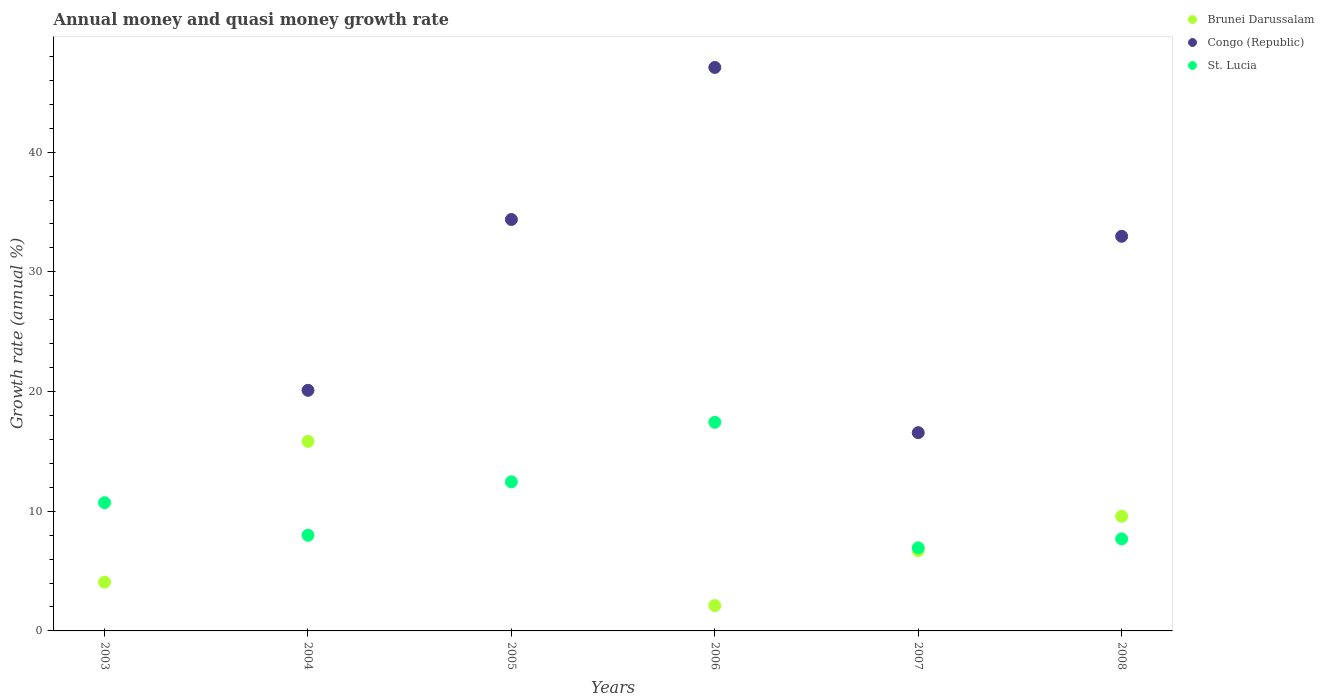Is the number of dotlines equal to the number of legend labels?
Offer a terse response. No. Across all years, what is the maximum growth rate in Congo (Republic)?
Give a very brief answer. 47.08. What is the total growth rate in Brunei Darussalam in the graph?
Your answer should be very brief. 38.31. What is the difference between the growth rate in Congo (Republic) in 2004 and that in 2006?
Provide a short and direct response. -26.97. What is the difference between the growth rate in St. Lucia in 2003 and the growth rate in Brunei Darussalam in 2007?
Offer a terse response. 4.01. What is the average growth rate in Brunei Darussalam per year?
Make the answer very short. 6.38. In the year 2008, what is the difference between the growth rate in St. Lucia and growth rate in Congo (Republic)?
Your answer should be very brief. -25.28. In how many years, is the growth rate in Brunei Darussalam greater than 16 %?
Provide a succinct answer. 0. What is the ratio of the growth rate in St. Lucia in 2003 to that in 2005?
Give a very brief answer. 0.86. What is the difference between the highest and the second highest growth rate in Brunei Darussalam?
Offer a terse response. 6.26. What is the difference between the highest and the lowest growth rate in Congo (Republic)?
Your response must be concise. 47.08. In how many years, is the growth rate in Brunei Darussalam greater than the average growth rate in Brunei Darussalam taken over all years?
Ensure brevity in your answer.  3. Does the growth rate in Congo (Republic) monotonically increase over the years?
Your answer should be compact. No. What is the difference between two consecutive major ticks on the Y-axis?
Provide a short and direct response. 10. Are the values on the major ticks of Y-axis written in scientific E-notation?
Offer a very short reply. No. Does the graph contain any zero values?
Your answer should be compact. Yes. Where does the legend appear in the graph?
Make the answer very short. Top right. What is the title of the graph?
Offer a terse response. Annual money and quasi money growth rate. What is the label or title of the Y-axis?
Keep it short and to the point. Growth rate (annual %). What is the Growth rate (annual %) in Brunei Darussalam in 2003?
Keep it short and to the point. 4.07. What is the Growth rate (annual %) in St. Lucia in 2003?
Offer a terse response. 10.71. What is the Growth rate (annual %) in Brunei Darussalam in 2004?
Give a very brief answer. 15.83. What is the Growth rate (annual %) in Congo (Republic) in 2004?
Keep it short and to the point. 20.1. What is the Growth rate (annual %) in St. Lucia in 2004?
Offer a terse response. 7.99. What is the Growth rate (annual %) in Congo (Republic) in 2005?
Keep it short and to the point. 34.37. What is the Growth rate (annual %) of St. Lucia in 2005?
Your answer should be very brief. 12.46. What is the Growth rate (annual %) of Brunei Darussalam in 2006?
Provide a short and direct response. 2.12. What is the Growth rate (annual %) in Congo (Republic) in 2006?
Give a very brief answer. 47.08. What is the Growth rate (annual %) in St. Lucia in 2006?
Your response must be concise. 17.43. What is the Growth rate (annual %) in Brunei Darussalam in 2007?
Make the answer very short. 6.71. What is the Growth rate (annual %) of Congo (Republic) in 2007?
Offer a very short reply. 16.56. What is the Growth rate (annual %) in St. Lucia in 2007?
Your response must be concise. 6.95. What is the Growth rate (annual %) of Brunei Darussalam in 2008?
Offer a terse response. 9.58. What is the Growth rate (annual %) in Congo (Republic) in 2008?
Your answer should be very brief. 32.97. What is the Growth rate (annual %) of St. Lucia in 2008?
Offer a very short reply. 7.69. Across all years, what is the maximum Growth rate (annual %) of Brunei Darussalam?
Provide a succinct answer. 15.83. Across all years, what is the maximum Growth rate (annual %) in Congo (Republic)?
Ensure brevity in your answer.  47.08. Across all years, what is the maximum Growth rate (annual %) of St. Lucia?
Your answer should be compact. 17.43. Across all years, what is the minimum Growth rate (annual %) of St. Lucia?
Offer a terse response. 6.95. What is the total Growth rate (annual %) in Brunei Darussalam in the graph?
Keep it short and to the point. 38.31. What is the total Growth rate (annual %) of Congo (Republic) in the graph?
Provide a short and direct response. 151.08. What is the total Growth rate (annual %) in St. Lucia in the graph?
Offer a terse response. 63.22. What is the difference between the Growth rate (annual %) in Brunei Darussalam in 2003 and that in 2004?
Offer a very short reply. -11.76. What is the difference between the Growth rate (annual %) in St. Lucia in 2003 and that in 2004?
Offer a terse response. 2.72. What is the difference between the Growth rate (annual %) of St. Lucia in 2003 and that in 2005?
Offer a terse response. -1.74. What is the difference between the Growth rate (annual %) of Brunei Darussalam in 2003 and that in 2006?
Keep it short and to the point. 1.95. What is the difference between the Growth rate (annual %) in St. Lucia in 2003 and that in 2006?
Provide a succinct answer. -6.72. What is the difference between the Growth rate (annual %) of Brunei Darussalam in 2003 and that in 2007?
Your response must be concise. -2.64. What is the difference between the Growth rate (annual %) in St. Lucia in 2003 and that in 2007?
Keep it short and to the point. 3.77. What is the difference between the Growth rate (annual %) of Brunei Darussalam in 2003 and that in 2008?
Provide a short and direct response. -5.51. What is the difference between the Growth rate (annual %) of St. Lucia in 2003 and that in 2008?
Provide a short and direct response. 3.02. What is the difference between the Growth rate (annual %) in Congo (Republic) in 2004 and that in 2005?
Your answer should be very brief. -14.27. What is the difference between the Growth rate (annual %) in St. Lucia in 2004 and that in 2005?
Your answer should be compact. -4.47. What is the difference between the Growth rate (annual %) in Brunei Darussalam in 2004 and that in 2006?
Give a very brief answer. 13.72. What is the difference between the Growth rate (annual %) of Congo (Republic) in 2004 and that in 2006?
Make the answer very short. -26.97. What is the difference between the Growth rate (annual %) of St. Lucia in 2004 and that in 2006?
Your response must be concise. -9.44. What is the difference between the Growth rate (annual %) of Brunei Darussalam in 2004 and that in 2007?
Your response must be concise. 9.13. What is the difference between the Growth rate (annual %) in Congo (Republic) in 2004 and that in 2007?
Provide a succinct answer. 3.54. What is the difference between the Growth rate (annual %) of St. Lucia in 2004 and that in 2007?
Your answer should be compact. 1.05. What is the difference between the Growth rate (annual %) in Brunei Darussalam in 2004 and that in 2008?
Ensure brevity in your answer.  6.26. What is the difference between the Growth rate (annual %) of Congo (Republic) in 2004 and that in 2008?
Make the answer very short. -12.87. What is the difference between the Growth rate (annual %) in St. Lucia in 2004 and that in 2008?
Keep it short and to the point. 0.3. What is the difference between the Growth rate (annual %) of Congo (Republic) in 2005 and that in 2006?
Ensure brevity in your answer.  -12.7. What is the difference between the Growth rate (annual %) in St. Lucia in 2005 and that in 2006?
Keep it short and to the point. -4.98. What is the difference between the Growth rate (annual %) of Congo (Republic) in 2005 and that in 2007?
Ensure brevity in your answer.  17.81. What is the difference between the Growth rate (annual %) of St. Lucia in 2005 and that in 2007?
Make the answer very short. 5.51. What is the difference between the Growth rate (annual %) in Congo (Republic) in 2005 and that in 2008?
Make the answer very short. 1.4. What is the difference between the Growth rate (annual %) in St. Lucia in 2005 and that in 2008?
Provide a short and direct response. 4.77. What is the difference between the Growth rate (annual %) in Brunei Darussalam in 2006 and that in 2007?
Your response must be concise. -4.59. What is the difference between the Growth rate (annual %) in Congo (Republic) in 2006 and that in 2007?
Give a very brief answer. 30.51. What is the difference between the Growth rate (annual %) in St. Lucia in 2006 and that in 2007?
Your answer should be compact. 10.49. What is the difference between the Growth rate (annual %) of Brunei Darussalam in 2006 and that in 2008?
Provide a short and direct response. -7.46. What is the difference between the Growth rate (annual %) of Congo (Republic) in 2006 and that in 2008?
Offer a terse response. 14.11. What is the difference between the Growth rate (annual %) in St. Lucia in 2006 and that in 2008?
Make the answer very short. 9.74. What is the difference between the Growth rate (annual %) in Brunei Darussalam in 2007 and that in 2008?
Ensure brevity in your answer.  -2.87. What is the difference between the Growth rate (annual %) of Congo (Republic) in 2007 and that in 2008?
Offer a terse response. -16.4. What is the difference between the Growth rate (annual %) of St. Lucia in 2007 and that in 2008?
Ensure brevity in your answer.  -0.74. What is the difference between the Growth rate (annual %) in Brunei Darussalam in 2003 and the Growth rate (annual %) in Congo (Republic) in 2004?
Provide a short and direct response. -16.03. What is the difference between the Growth rate (annual %) in Brunei Darussalam in 2003 and the Growth rate (annual %) in St. Lucia in 2004?
Keep it short and to the point. -3.92. What is the difference between the Growth rate (annual %) of Brunei Darussalam in 2003 and the Growth rate (annual %) of Congo (Republic) in 2005?
Your answer should be very brief. -30.3. What is the difference between the Growth rate (annual %) in Brunei Darussalam in 2003 and the Growth rate (annual %) in St. Lucia in 2005?
Give a very brief answer. -8.39. What is the difference between the Growth rate (annual %) in Brunei Darussalam in 2003 and the Growth rate (annual %) in Congo (Republic) in 2006?
Offer a very short reply. -43. What is the difference between the Growth rate (annual %) in Brunei Darussalam in 2003 and the Growth rate (annual %) in St. Lucia in 2006?
Provide a succinct answer. -13.36. What is the difference between the Growth rate (annual %) in Brunei Darussalam in 2003 and the Growth rate (annual %) in Congo (Republic) in 2007?
Provide a short and direct response. -12.49. What is the difference between the Growth rate (annual %) of Brunei Darussalam in 2003 and the Growth rate (annual %) of St. Lucia in 2007?
Provide a succinct answer. -2.87. What is the difference between the Growth rate (annual %) of Brunei Darussalam in 2003 and the Growth rate (annual %) of Congo (Republic) in 2008?
Provide a short and direct response. -28.9. What is the difference between the Growth rate (annual %) of Brunei Darussalam in 2003 and the Growth rate (annual %) of St. Lucia in 2008?
Your response must be concise. -3.62. What is the difference between the Growth rate (annual %) of Brunei Darussalam in 2004 and the Growth rate (annual %) of Congo (Republic) in 2005?
Your answer should be very brief. -18.54. What is the difference between the Growth rate (annual %) of Brunei Darussalam in 2004 and the Growth rate (annual %) of St. Lucia in 2005?
Offer a very short reply. 3.38. What is the difference between the Growth rate (annual %) of Congo (Republic) in 2004 and the Growth rate (annual %) of St. Lucia in 2005?
Provide a succinct answer. 7.64. What is the difference between the Growth rate (annual %) in Brunei Darussalam in 2004 and the Growth rate (annual %) in Congo (Republic) in 2006?
Offer a very short reply. -31.24. What is the difference between the Growth rate (annual %) of Brunei Darussalam in 2004 and the Growth rate (annual %) of St. Lucia in 2006?
Provide a succinct answer. -1.6. What is the difference between the Growth rate (annual %) in Congo (Republic) in 2004 and the Growth rate (annual %) in St. Lucia in 2006?
Your answer should be compact. 2.67. What is the difference between the Growth rate (annual %) in Brunei Darussalam in 2004 and the Growth rate (annual %) in Congo (Republic) in 2007?
Provide a short and direct response. -0.73. What is the difference between the Growth rate (annual %) of Brunei Darussalam in 2004 and the Growth rate (annual %) of St. Lucia in 2007?
Your answer should be very brief. 8.89. What is the difference between the Growth rate (annual %) in Congo (Republic) in 2004 and the Growth rate (annual %) in St. Lucia in 2007?
Give a very brief answer. 13.16. What is the difference between the Growth rate (annual %) in Brunei Darussalam in 2004 and the Growth rate (annual %) in Congo (Republic) in 2008?
Ensure brevity in your answer.  -17.13. What is the difference between the Growth rate (annual %) of Brunei Darussalam in 2004 and the Growth rate (annual %) of St. Lucia in 2008?
Offer a very short reply. 8.15. What is the difference between the Growth rate (annual %) in Congo (Republic) in 2004 and the Growth rate (annual %) in St. Lucia in 2008?
Offer a very short reply. 12.41. What is the difference between the Growth rate (annual %) of Congo (Republic) in 2005 and the Growth rate (annual %) of St. Lucia in 2006?
Your response must be concise. 16.94. What is the difference between the Growth rate (annual %) in Congo (Republic) in 2005 and the Growth rate (annual %) in St. Lucia in 2007?
Provide a succinct answer. 27.43. What is the difference between the Growth rate (annual %) of Congo (Republic) in 2005 and the Growth rate (annual %) of St. Lucia in 2008?
Make the answer very short. 26.68. What is the difference between the Growth rate (annual %) of Brunei Darussalam in 2006 and the Growth rate (annual %) of Congo (Republic) in 2007?
Your response must be concise. -14.45. What is the difference between the Growth rate (annual %) of Brunei Darussalam in 2006 and the Growth rate (annual %) of St. Lucia in 2007?
Provide a short and direct response. -4.83. What is the difference between the Growth rate (annual %) of Congo (Republic) in 2006 and the Growth rate (annual %) of St. Lucia in 2007?
Offer a very short reply. 40.13. What is the difference between the Growth rate (annual %) in Brunei Darussalam in 2006 and the Growth rate (annual %) in Congo (Republic) in 2008?
Give a very brief answer. -30.85. What is the difference between the Growth rate (annual %) in Brunei Darussalam in 2006 and the Growth rate (annual %) in St. Lucia in 2008?
Provide a short and direct response. -5.57. What is the difference between the Growth rate (annual %) in Congo (Republic) in 2006 and the Growth rate (annual %) in St. Lucia in 2008?
Your answer should be very brief. 39.39. What is the difference between the Growth rate (annual %) in Brunei Darussalam in 2007 and the Growth rate (annual %) in Congo (Republic) in 2008?
Offer a very short reply. -26.26. What is the difference between the Growth rate (annual %) in Brunei Darussalam in 2007 and the Growth rate (annual %) in St. Lucia in 2008?
Your answer should be compact. -0.98. What is the difference between the Growth rate (annual %) of Congo (Republic) in 2007 and the Growth rate (annual %) of St. Lucia in 2008?
Offer a terse response. 8.88. What is the average Growth rate (annual %) of Brunei Darussalam per year?
Your response must be concise. 6.38. What is the average Growth rate (annual %) of Congo (Republic) per year?
Your response must be concise. 25.18. What is the average Growth rate (annual %) of St. Lucia per year?
Make the answer very short. 10.54. In the year 2003, what is the difference between the Growth rate (annual %) in Brunei Darussalam and Growth rate (annual %) in St. Lucia?
Your answer should be very brief. -6.64. In the year 2004, what is the difference between the Growth rate (annual %) of Brunei Darussalam and Growth rate (annual %) of Congo (Republic)?
Offer a terse response. -4.27. In the year 2004, what is the difference between the Growth rate (annual %) in Brunei Darussalam and Growth rate (annual %) in St. Lucia?
Keep it short and to the point. 7.84. In the year 2004, what is the difference between the Growth rate (annual %) in Congo (Republic) and Growth rate (annual %) in St. Lucia?
Provide a short and direct response. 12.11. In the year 2005, what is the difference between the Growth rate (annual %) in Congo (Republic) and Growth rate (annual %) in St. Lucia?
Provide a succinct answer. 21.92. In the year 2006, what is the difference between the Growth rate (annual %) of Brunei Darussalam and Growth rate (annual %) of Congo (Republic)?
Give a very brief answer. -44.96. In the year 2006, what is the difference between the Growth rate (annual %) of Brunei Darussalam and Growth rate (annual %) of St. Lucia?
Ensure brevity in your answer.  -15.31. In the year 2006, what is the difference between the Growth rate (annual %) in Congo (Republic) and Growth rate (annual %) in St. Lucia?
Provide a short and direct response. 29.64. In the year 2007, what is the difference between the Growth rate (annual %) in Brunei Darussalam and Growth rate (annual %) in Congo (Republic)?
Offer a very short reply. -9.86. In the year 2007, what is the difference between the Growth rate (annual %) of Brunei Darussalam and Growth rate (annual %) of St. Lucia?
Give a very brief answer. -0.24. In the year 2007, what is the difference between the Growth rate (annual %) in Congo (Republic) and Growth rate (annual %) in St. Lucia?
Ensure brevity in your answer.  9.62. In the year 2008, what is the difference between the Growth rate (annual %) in Brunei Darussalam and Growth rate (annual %) in Congo (Republic)?
Provide a short and direct response. -23.39. In the year 2008, what is the difference between the Growth rate (annual %) of Brunei Darussalam and Growth rate (annual %) of St. Lucia?
Keep it short and to the point. 1.89. In the year 2008, what is the difference between the Growth rate (annual %) of Congo (Republic) and Growth rate (annual %) of St. Lucia?
Provide a short and direct response. 25.28. What is the ratio of the Growth rate (annual %) in Brunei Darussalam in 2003 to that in 2004?
Your answer should be compact. 0.26. What is the ratio of the Growth rate (annual %) of St. Lucia in 2003 to that in 2004?
Provide a short and direct response. 1.34. What is the ratio of the Growth rate (annual %) in St. Lucia in 2003 to that in 2005?
Offer a terse response. 0.86. What is the ratio of the Growth rate (annual %) of Brunei Darussalam in 2003 to that in 2006?
Your answer should be very brief. 1.92. What is the ratio of the Growth rate (annual %) in St. Lucia in 2003 to that in 2006?
Provide a succinct answer. 0.61. What is the ratio of the Growth rate (annual %) in Brunei Darussalam in 2003 to that in 2007?
Provide a succinct answer. 0.61. What is the ratio of the Growth rate (annual %) of St. Lucia in 2003 to that in 2007?
Offer a terse response. 1.54. What is the ratio of the Growth rate (annual %) of Brunei Darussalam in 2003 to that in 2008?
Provide a succinct answer. 0.42. What is the ratio of the Growth rate (annual %) of St. Lucia in 2003 to that in 2008?
Offer a terse response. 1.39. What is the ratio of the Growth rate (annual %) in Congo (Republic) in 2004 to that in 2005?
Your response must be concise. 0.58. What is the ratio of the Growth rate (annual %) of St. Lucia in 2004 to that in 2005?
Give a very brief answer. 0.64. What is the ratio of the Growth rate (annual %) in Brunei Darussalam in 2004 to that in 2006?
Ensure brevity in your answer.  7.48. What is the ratio of the Growth rate (annual %) of Congo (Republic) in 2004 to that in 2006?
Make the answer very short. 0.43. What is the ratio of the Growth rate (annual %) in St. Lucia in 2004 to that in 2006?
Ensure brevity in your answer.  0.46. What is the ratio of the Growth rate (annual %) in Brunei Darussalam in 2004 to that in 2007?
Keep it short and to the point. 2.36. What is the ratio of the Growth rate (annual %) in Congo (Republic) in 2004 to that in 2007?
Your response must be concise. 1.21. What is the ratio of the Growth rate (annual %) of St. Lucia in 2004 to that in 2007?
Give a very brief answer. 1.15. What is the ratio of the Growth rate (annual %) of Brunei Darussalam in 2004 to that in 2008?
Keep it short and to the point. 1.65. What is the ratio of the Growth rate (annual %) in Congo (Republic) in 2004 to that in 2008?
Your answer should be compact. 0.61. What is the ratio of the Growth rate (annual %) in St. Lucia in 2004 to that in 2008?
Your answer should be compact. 1.04. What is the ratio of the Growth rate (annual %) in Congo (Republic) in 2005 to that in 2006?
Provide a succinct answer. 0.73. What is the ratio of the Growth rate (annual %) in St. Lucia in 2005 to that in 2006?
Offer a very short reply. 0.71. What is the ratio of the Growth rate (annual %) in Congo (Republic) in 2005 to that in 2007?
Give a very brief answer. 2.08. What is the ratio of the Growth rate (annual %) of St. Lucia in 2005 to that in 2007?
Make the answer very short. 1.79. What is the ratio of the Growth rate (annual %) of Congo (Republic) in 2005 to that in 2008?
Your response must be concise. 1.04. What is the ratio of the Growth rate (annual %) of St. Lucia in 2005 to that in 2008?
Provide a short and direct response. 1.62. What is the ratio of the Growth rate (annual %) in Brunei Darussalam in 2006 to that in 2007?
Offer a very short reply. 0.32. What is the ratio of the Growth rate (annual %) in Congo (Republic) in 2006 to that in 2007?
Offer a very short reply. 2.84. What is the ratio of the Growth rate (annual %) in St. Lucia in 2006 to that in 2007?
Give a very brief answer. 2.51. What is the ratio of the Growth rate (annual %) in Brunei Darussalam in 2006 to that in 2008?
Ensure brevity in your answer.  0.22. What is the ratio of the Growth rate (annual %) of Congo (Republic) in 2006 to that in 2008?
Your response must be concise. 1.43. What is the ratio of the Growth rate (annual %) in St. Lucia in 2006 to that in 2008?
Offer a terse response. 2.27. What is the ratio of the Growth rate (annual %) of Brunei Darussalam in 2007 to that in 2008?
Your answer should be compact. 0.7. What is the ratio of the Growth rate (annual %) in Congo (Republic) in 2007 to that in 2008?
Offer a very short reply. 0.5. What is the ratio of the Growth rate (annual %) in St. Lucia in 2007 to that in 2008?
Keep it short and to the point. 0.9. What is the difference between the highest and the second highest Growth rate (annual %) of Brunei Darussalam?
Make the answer very short. 6.26. What is the difference between the highest and the second highest Growth rate (annual %) of Congo (Republic)?
Give a very brief answer. 12.7. What is the difference between the highest and the second highest Growth rate (annual %) in St. Lucia?
Offer a terse response. 4.98. What is the difference between the highest and the lowest Growth rate (annual %) in Brunei Darussalam?
Give a very brief answer. 15.83. What is the difference between the highest and the lowest Growth rate (annual %) in Congo (Republic)?
Your response must be concise. 47.08. What is the difference between the highest and the lowest Growth rate (annual %) of St. Lucia?
Your answer should be very brief. 10.49. 